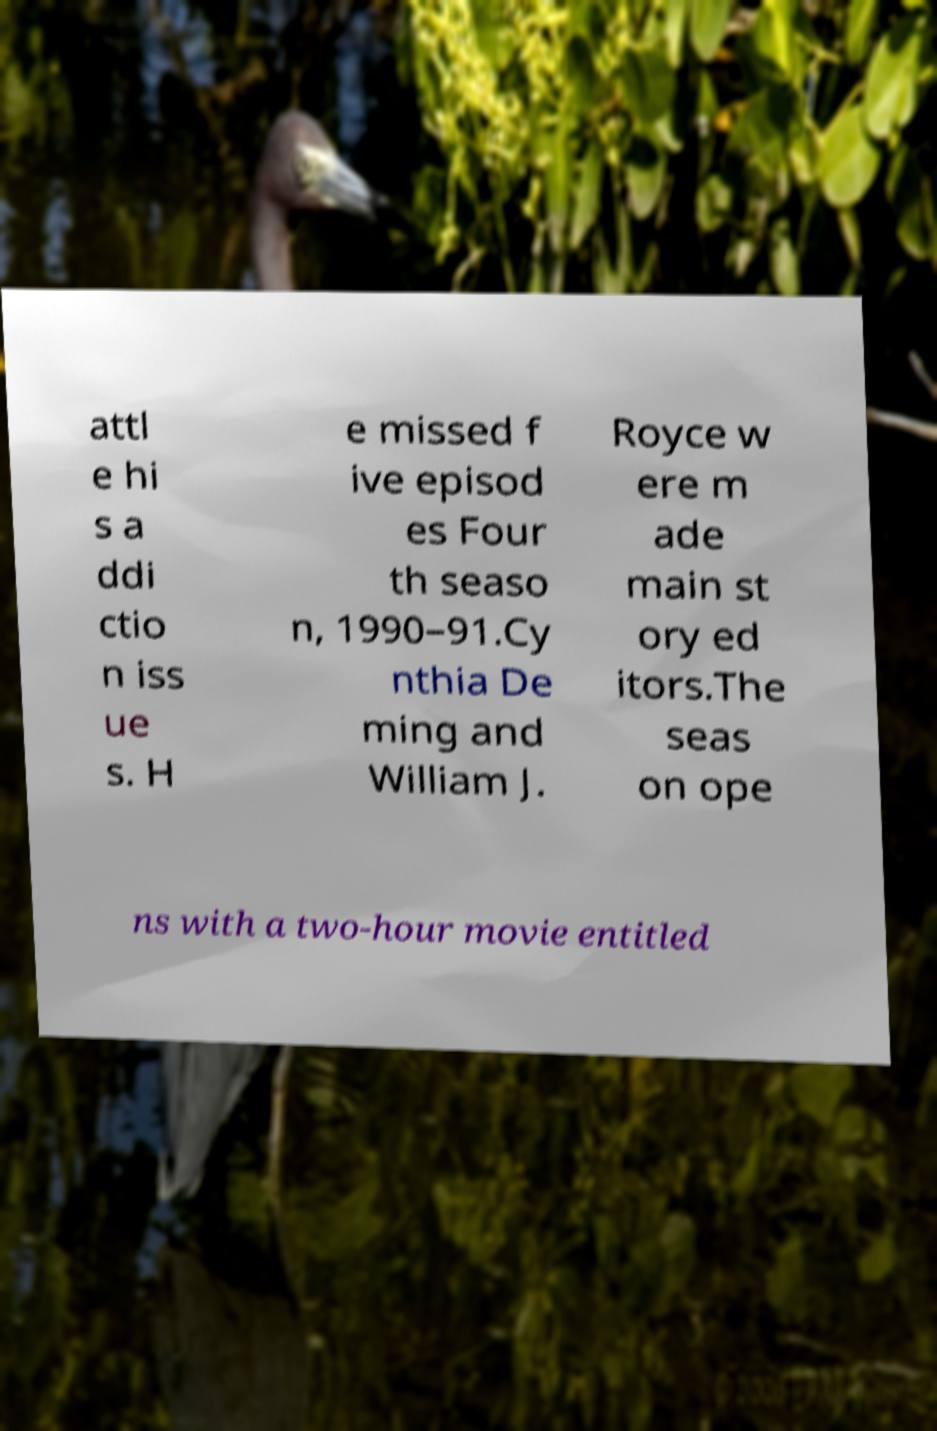There's text embedded in this image that I need extracted. Can you transcribe it verbatim? attl e hi s a ddi ctio n iss ue s. H e missed f ive episod es Four th seaso n, 1990–91.Cy nthia De ming and William J. Royce w ere m ade main st ory ed itors.The seas on ope ns with a two-hour movie entitled 